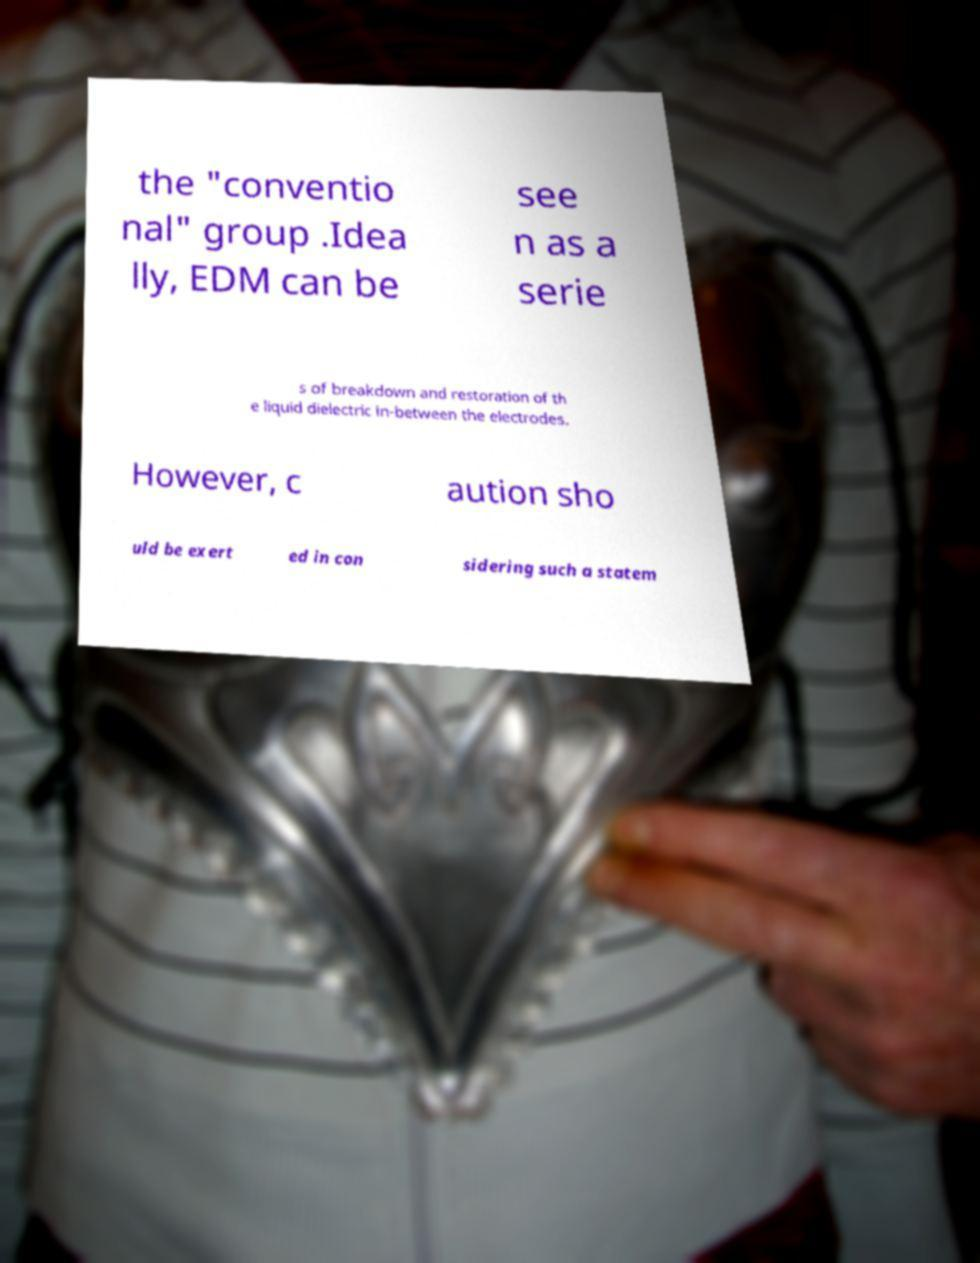Please read and relay the text visible in this image. What does it say? the "conventio nal" group .Idea lly, EDM can be see n as a serie s of breakdown and restoration of th e liquid dielectric in-between the electrodes. However, c aution sho uld be exert ed in con sidering such a statem 